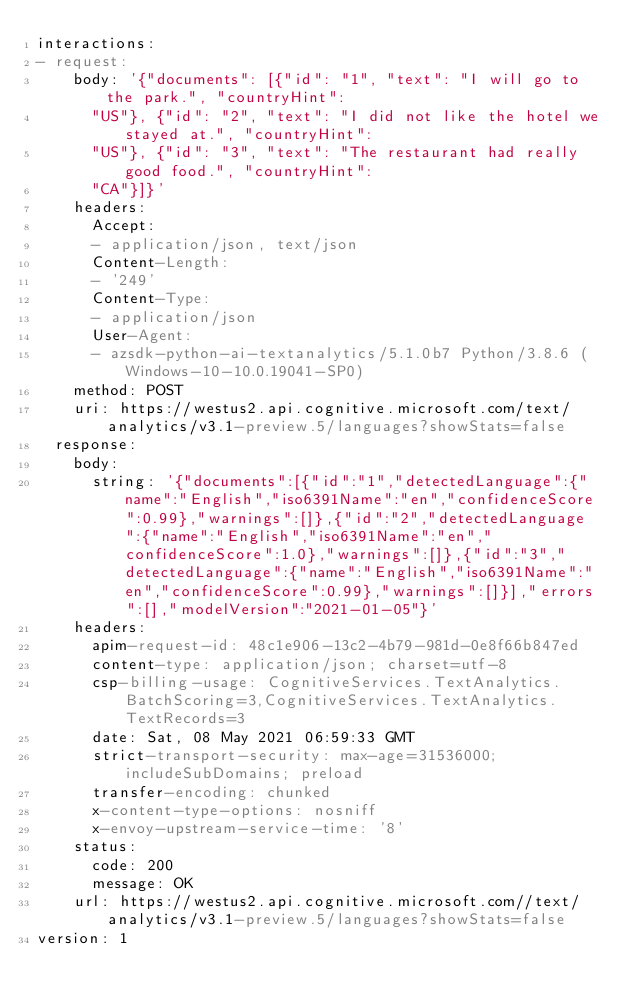<code> <loc_0><loc_0><loc_500><loc_500><_YAML_>interactions:
- request:
    body: '{"documents": [{"id": "1", "text": "I will go to the park.", "countryHint":
      "US"}, {"id": "2", "text": "I did not like the hotel we stayed at.", "countryHint":
      "US"}, {"id": "3", "text": "The restaurant had really good food.", "countryHint":
      "CA"}]}'
    headers:
      Accept:
      - application/json, text/json
      Content-Length:
      - '249'
      Content-Type:
      - application/json
      User-Agent:
      - azsdk-python-ai-textanalytics/5.1.0b7 Python/3.8.6 (Windows-10-10.0.19041-SP0)
    method: POST
    uri: https://westus2.api.cognitive.microsoft.com/text/analytics/v3.1-preview.5/languages?showStats=false
  response:
    body:
      string: '{"documents":[{"id":"1","detectedLanguage":{"name":"English","iso6391Name":"en","confidenceScore":0.99},"warnings":[]},{"id":"2","detectedLanguage":{"name":"English","iso6391Name":"en","confidenceScore":1.0},"warnings":[]},{"id":"3","detectedLanguage":{"name":"English","iso6391Name":"en","confidenceScore":0.99},"warnings":[]}],"errors":[],"modelVersion":"2021-01-05"}'
    headers:
      apim-request-id: 48c1e906-13c2-4b79-981d-0e8f66b847ed
      content-type: application/json; charset=utf-8
      csp-billing-usage: CognitiveServices.TextAnalytics.BatchScoring=3,CognitiveServices.TextAnalytics.TextRecords=3
      date: Sat, 08 May 2021 06:59:33 GMT
      strict-transport-security: max-age=31536000; includeSubDomains; preload
      transfer-encoding: chunked
      x-content-type-options: nosniff
      x-envoy-upstream-service-time: '8'
    status:
      code: 200
      message: OK
    url: https://westus2.api.cognitive.microsoft.com//text/analytics/v3.1-preview.5/languages?showStats=false
version: 1
</code> 